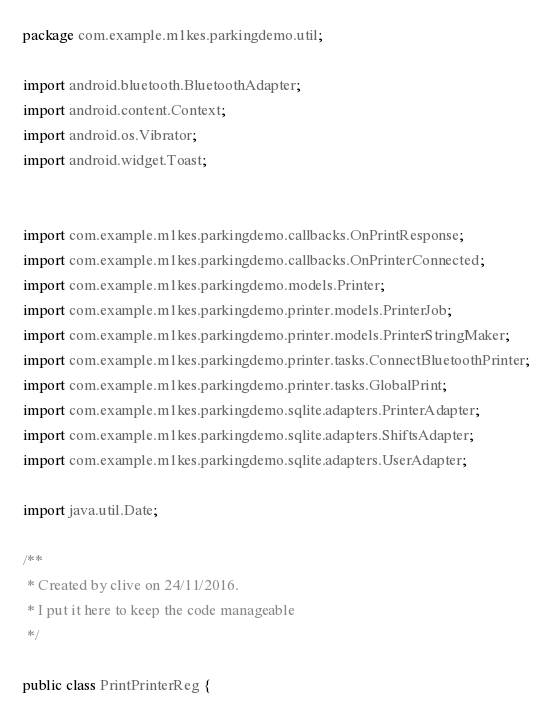<code> <loc_0><loc_0><loc_500><loc_500><_Java_>package com.example.m1kes.parkingdemo.util;

import android.bluetooth.BluetoothAdapter;
import android.content.Context;
import android.os.Vibrator;
import android.widget.Toast;


import com.example.m1kes.parkingdemo.callbacks.OnPrintResponse;
import com.example.m1kes.parkingdemo.callbacks.OnPrinterConnected;
import com.example.m1kes.parkingdemo.models.Printer;
import com.example.m1kes.parkingdemo.printer.models.PrinterJob;
import com.example.m1kes.parkingdemo.printer.models.PrinterStringMaker;
import com.example.m1kes.parkingdemo.printer.tasks.ConnectBluetoothPrinter;
import com.example.m1kes.parkingdemo.printer.tasks.GlobalPrint;
import com.example.m1kes.parkingdemo.sqlite.adapters.PrinterAdapter;
import com.example.m1kes.parkingdemo.sqlite.adapters.ShiftsAdapter;
import com.example.m1kes.parkingdemo.sqlite.adapters.UserAdapter;

import java.util.Date;

/**
 * Created by clive on 24/11/2016.
 * I put it here to keep the code manageable
 */

public class PrintPrinterReg {
</code> 